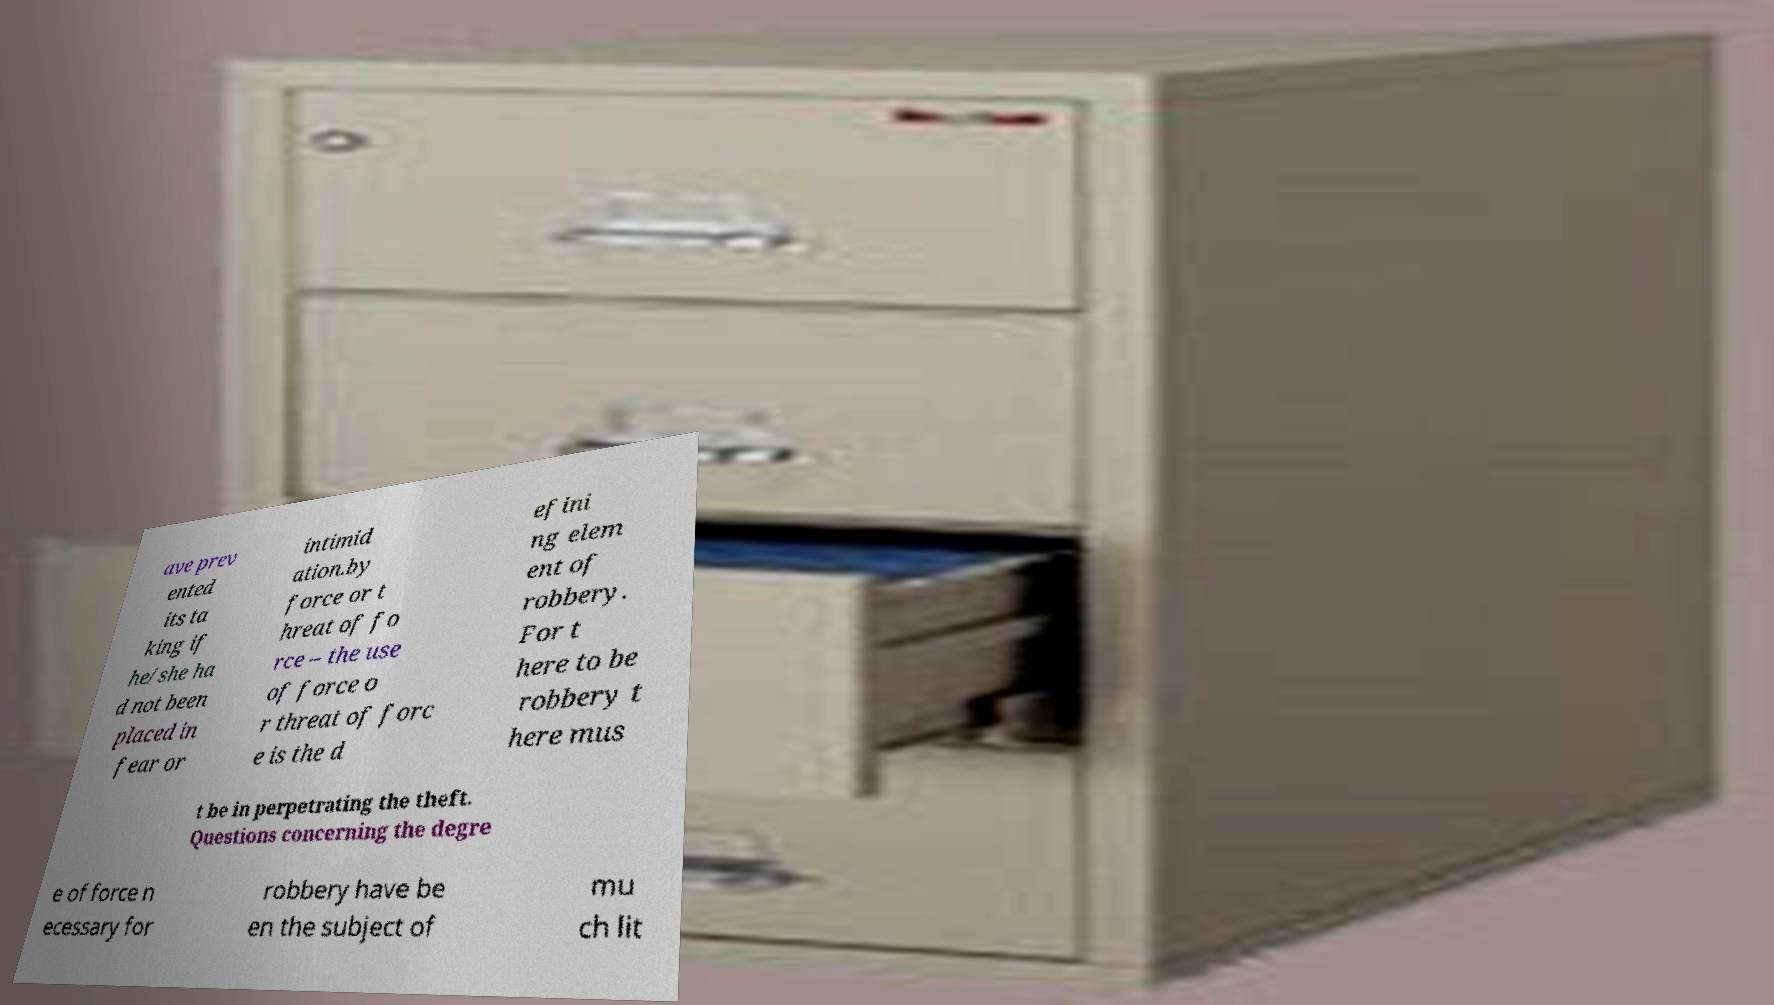Can you accurately transcribe the text from the provided image for me? ave prev ented its ta king if he/she ha d not been placed in fear or intimid ation.by force or t hreat of fo rce – the use of force o r threat of forc e is the d efini ng elem ent of robbery. For t here to be robbery t here mus t be in perpetrating the theft. Questions concerning the degre e of force n ecessary for robbery have be en the subject of mu ch lit 